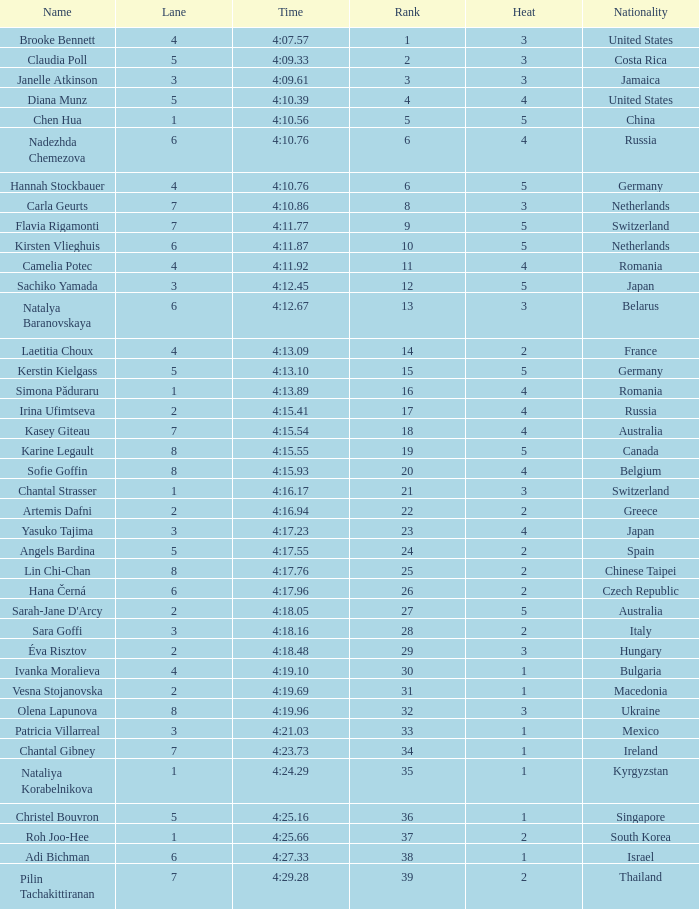Name the average rank with larger than 3 and heat more than 5 None. 